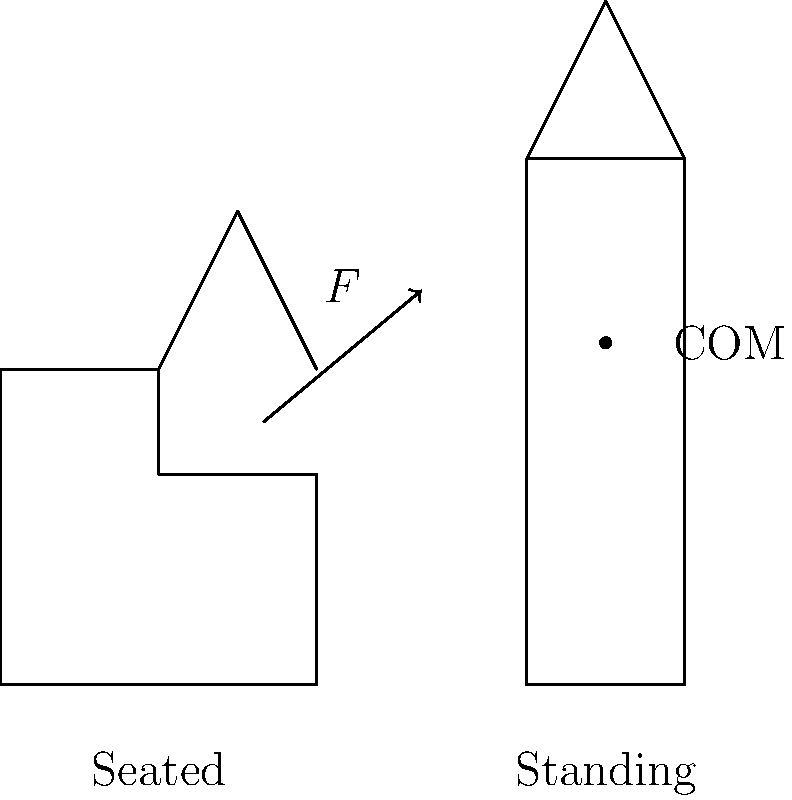An elderly man weighing 75 kg and standing 170 cm tall needs assistance to move from a seated to a standing position. Assuming his center of mass (COM) moves vertically by 50 cm during this transition, what minimum force $F$ is required to safely assist him, given that the force should be applied at a 45-degree angle to the horizontal? (Use $g = 9.8$ m/s²) To solve this problem, we'll follow these steps:

1) The work done to lift the person is equal to the change in potential energy:
   $W = mgh$
   Where $m$ is mass, $g$ is acceleration due to gravity, and $h$ is height change.

2) Calculate the work:
   $W = 75 \text{ kg} \times 9.8 \text{ m/s²} \times 0.5 \text{ m} = 367.5 \text{ J}$

3) The work done by the applied force $F$ is:
   $W = F \times d \times \cos{\theta}$
   Where $d$ is the distance the force is applied, and $\theta$ is the angle from the direction of motion.

4) The vertical component of the force does the work:
   $367.5 \text{ J} = F \times 0.5 \text{ m} \times \cos{45°}$

5) Solve for $F$:
   $F = \frac{367.5 \text{ J}}{0.5 \text{ m} \times \cos{45°}} = \frac{367.5}{0.5 \times \frac{\sqrt{2}}{2}} = 1039.2 \text{ N}$

Therefore, the minimum force required is approximately 1039.2 N or about 106 kg-force.
Answer: 1039.2 N 